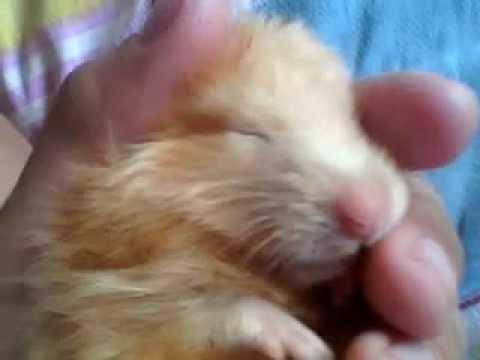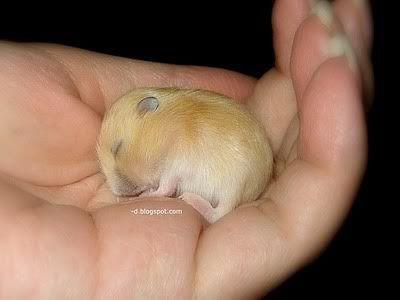The first image is the image on the left, the second image is the image on the right. Analyze the images presented: Is the assertion "The hamsters are all the same color." valid? Answer yes or no. Yes. The first image is the image on the left, the second image is the image on the right. Analyze the images presented: Is the assertion "Each image shows a hand holding exactly one pet rodent, and each pet rodent is held, but not grasped, in an upturned hand." valid? Answer yes or no. No. 